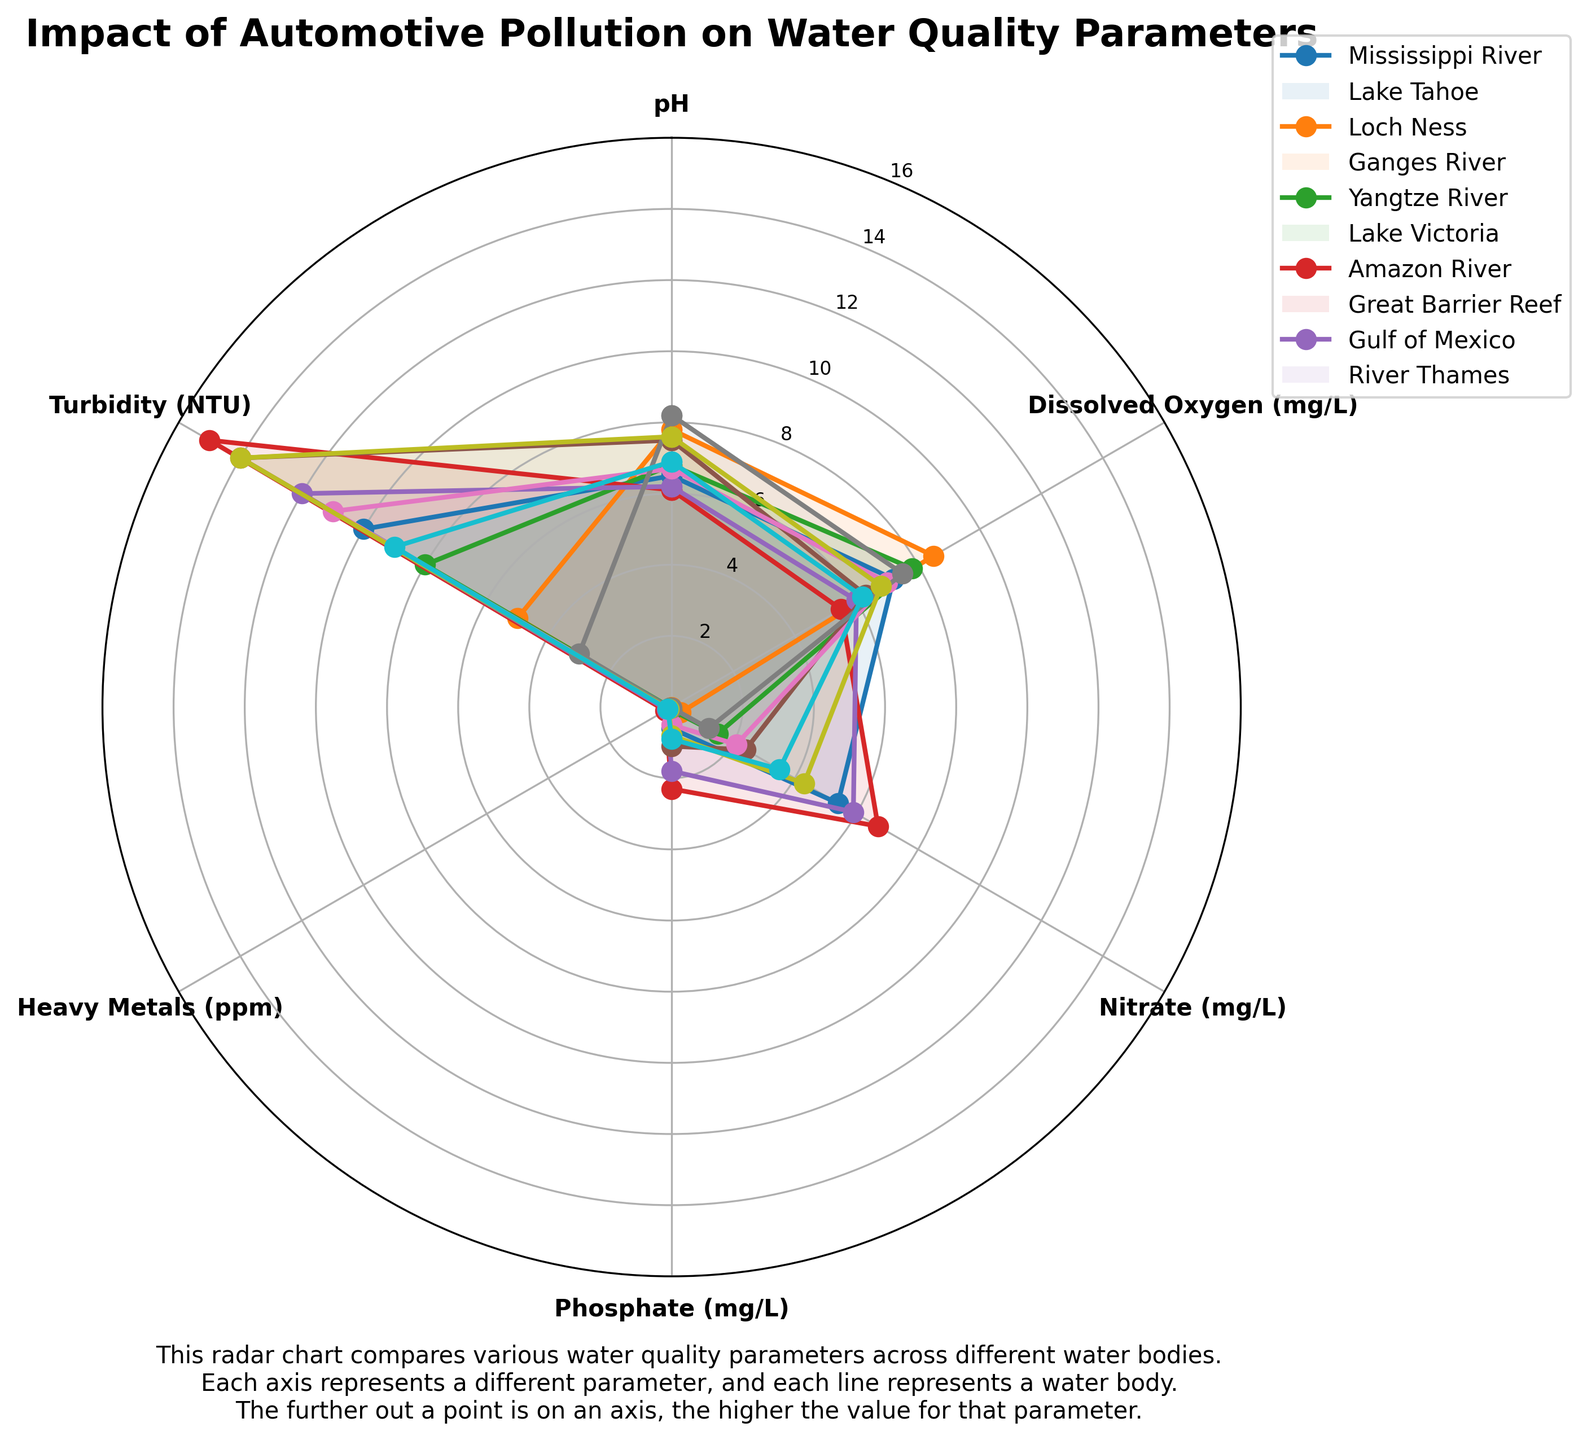What's the title of the plot? The title is usually at the top of the radar chart, and it provides an overview of what the chart depicts. In this case, you can find the title just above the plot.
Answer: Impact of Automotive Pollution on Water Quality Parameters Which water body has the highest pH level? In the radar chart, pH levels are represented along one of the radial axes. By visually inspecting the markers and lines for each water body on the pH axis, you can identify which one extends furthest on that axis.
Answer: Great Barrier Reef (8.2) What are the two water bodies with the lowest dissolved oxygen levels? To find the lowest dissolved oxygen levels, check the radial axis labeled "Dissolved Oxygen (mg/L)" and observe which lines and markers are closest to the center. The two lowest points indicate the water bodies with the lowest levels.
Answer: Ganges River (5.5) and River Thames (6.2) Which parameter has the highest value for the Ganges River? Look at the line or markers representing the Ganges River and identify which axis it extends furthest along. Each axis represents a different parameter.
Answer: Nitrate (6.7 mg/L) Compare the nitrate levels between Lake Tahoe and Lake Victoria. Which one is higher and by how much? Observe the positions of Lake Tahoe and Lake Victoria on the "Nitrate (mg/L)" axis. Measure the radial distance of each and subtract the smaller value from the larger one.
Answer: Lake Victoria is higher by 2.1 mg/L (2.4 - 0.3) Which water bodies have higher turbidity levels than the Mississippi River? Check the radial positions for the water bodies on the "Turbidity (NTU)" axis. Identify which ones have markers or lines extending further from the center compared to the Mississippi River.
Answer: Ganges River (15), Lake Victoria (14), Gulf of Mexico (14), Amazon River (11) What is the average dissolved oxygen level across all water bodies? Collect the dissolved oxygen values for each water body and sum them up, then divide by the total number of water bodies (10). Sum: 7.2 + 8.5 + 7.8 + 5.5 + 6.0 + 6.3 + 7.0 + 7.5 + 6.8 + 6.2 = 68.8. Divide by 10.
Answer: 6.88 mg/L According to the chart, which parameter seems to be most consistently similar across all water bodies? Find the parameter axis where the lines and markers for different water bodies are closest to one another, indicating less variability.
Answer: Heavy Metals (ppm) Is the turbidity in the Gulf of Mexico higher or lower than in Loch Ness? Look at the positions on the "Turbidity (NTU)" axis and compare the radial distances for Gulf of Mexico and Loch Ness.
Answer: Higher (Gulf of Mexico: 14, Loch Ness: 8) Which water body has the lowest phosphate level? Check the positions of the markers/lines on the "Phosphate (mg/L)" axis and find the one closest to the center.
Answer: Lake Tahoe (0.01 mg/L) 